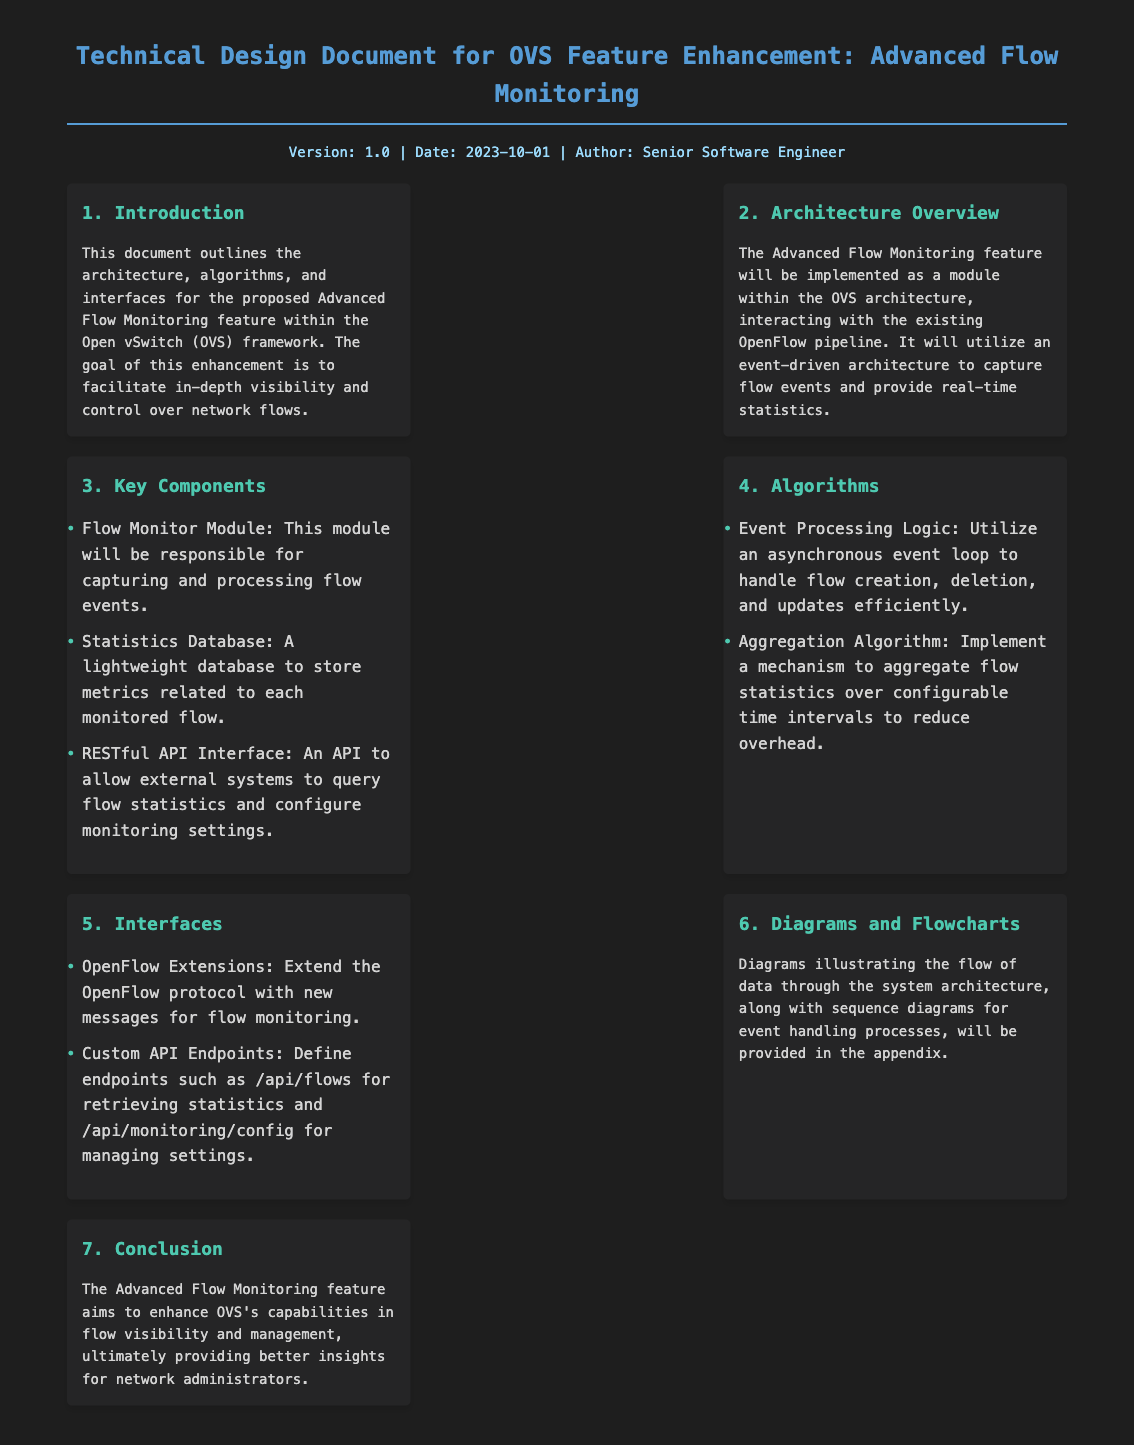What is the title of the document? The title provides the main subject of the document, which is "Technical Design Document for OVS Feature Enhancement: Advanced Flow Monitoring".
Answer: Technical Design Document for OVS Feature Enhancement: Advanced Flow Monitoring What is the version number of the document? The version number is stated in the meta-info section, which indicates the current version of the document.
Answer: 1.0 When was the document published? The date of publication is included in the meta-info section.
Answer: 2023-10-01 Who is the author of the document? The author is credited in the meta-info section of the document.
Answer: Senior Software Engineer What is the main goal of the proposed feature? The introduction outlines the main goal of the Advanced Flow Monitoring feature.
Answer: Facilitate in-depth visibility and control over network flows What type of architecture will the feature use? The architecture overview states the design approach for the enhancement.
Answer: Event-driven architecture How many key components are listed in the document? The number of components is determined by counting the items in the Key Components section.
Answer: Three What is one algorithm mentioned in the document? The algorithms section provides specific algorithms used in the feature implementation.
Answer: Event Processing Logic What is one of the custom API endpoints defined? The interfaces section describes specific endpoints for interaction with the feature.
Answer: /api/flows 